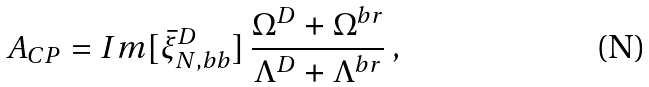<formula> <loc_0><loc_0><loc_500><loc_500>A _ { C P } = I m [ \bar { \xi } ^ { D } _ { N , b b } ] \, \frac { \Omega ^ { D } + \Omega ^ { b r } } { \Lambda ^ { D } + \Lambda ^ { b r } } \, ,</formula> 